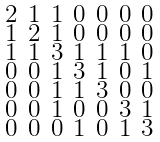<formula> <loc_0><loc_0><loc_500><loc_500>\begin{smallmatrix} 2 & 1 & 1 & 0 & 0 & 0 & 0 \\ 1 & 2 & 1 & 0 & 0 & 0 & 0 \\ 1 & 1 & 3 & 1 & 1 & 1 & 0 \\ 0 & 0 & 1 & 3 & 1 & 0 & 1 \\ 0 & 0 & 1 & 1 & 3 & 0 & 0 \\ 0 & 0 & 1 & 0 & 0 & 3 & 1 \\ 0 & 0 & 0 & 1 & 0 & 1 & 3 \end{smallmatrix}</formula> 